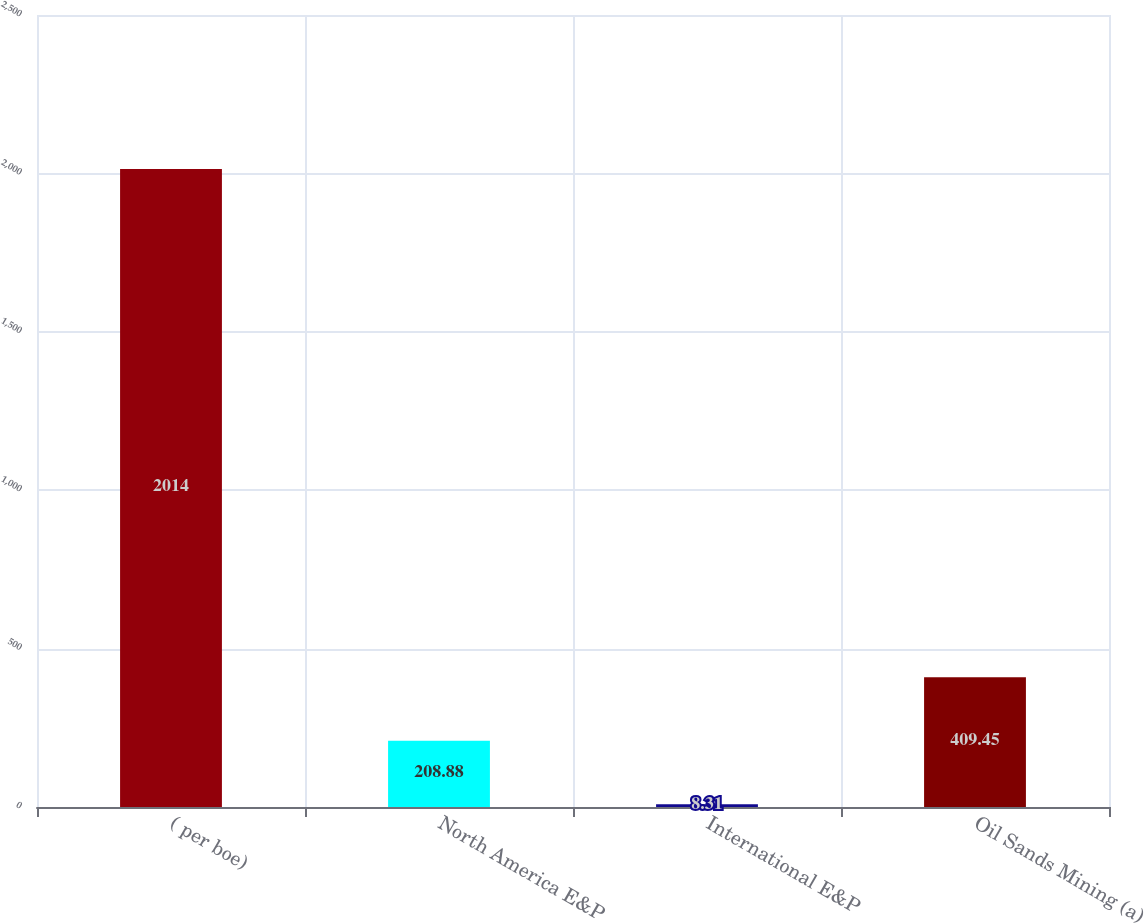<chart> <loc_0><loc_0><loc_500><loc_500><bar_chart><fcel>( per boe)<fcel>North America E&P<fcel>International E&P<fcel>Oil Sands Mining (a)<nl><fcel>2014<fcel>208.88<fcel>8.31<fcel>409.45<nl></chart> 